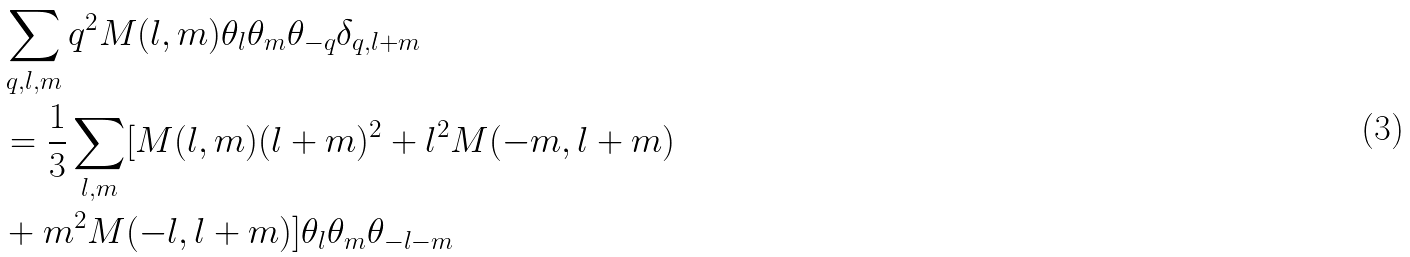<formula> <loc_0><loc_0><loc_500><loc_500>& \sum _ { q , l , m } { q } ^ { 2 } M ( { l } , { m } ) \theta _ { l } \theta _ { m } \theta _ { - { q } } \delta _ { q , l + m } \\ & = \frac { 1 } { 3 } \sum _ { l , m } [ M ( { l } , { m } ) ( { l } + { m } ) ^ { 2 } + { l } ^ { 2 } M ( - { m } , { l } + { m } ) \\ & + { m } ^ { 2 } M ( - { l } , { l } + { m } ) ] \theta _ { l } \theta _ { m } \theta _ { - { l } - { m } }</formula> 